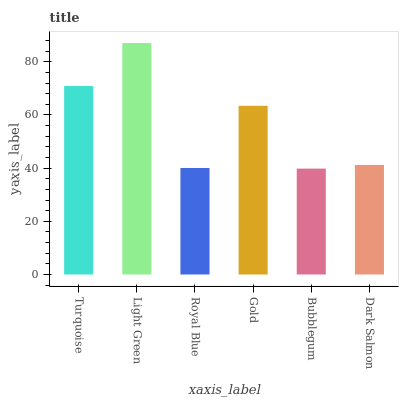Is Bubblegum the minimum?
Answer yes or no. Yes. Is Light Green the maximum?
Answer yes or no. Yes. Is Royal Blue the minimum?
Answer yes or no. No. Is Royal Blue the maximum?
Answer yes or no. No. Is Light Green greater than Royal Blue?
Answer yes or no. Yes. Is Royal Blue less than Light Green?
Answer yes or no. Yes. Is Royal Blue greater than Light Green?
Answer yes or no. No. Is Light Green less than Royal Blue?
Answer yes or no. No. Is Gold the high median?
Answer yes or no. Yes. Is Dark Salmon the low median?
Answer yes or no. Yes. Is Bubblegum the high median?
Answer yes or no. No. Is Light Green the low median?
Answer yes or no. No. 